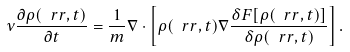<formula> <loc_0><loc_0><loc_500><loc_500>\nu \frac { \partial \rho ( \ r r , t ) } { \partial t } = \frac { 1 } { m } \nabla \cdot \left [ \rho ( \ r r , t ) \nabla \frac { \delta F [ \rho ( \ r r , t ) ] } { \delta \rho ( \ r r , t ) } \right ] .</formula> 